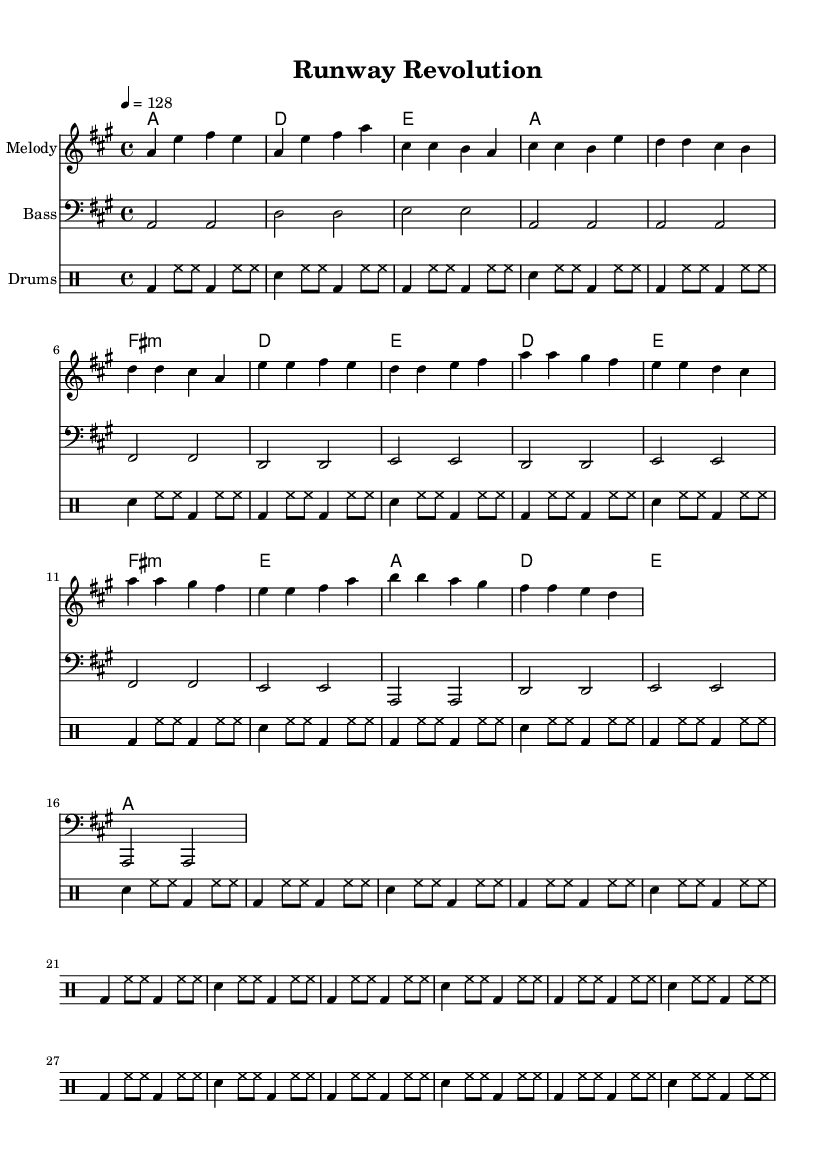What is the key signature of this music? The key signature is A major, which has three sharps: F#, C#, and G#. This is indicated at the beginning of the score.
Answer: A major What is the time signature of this piece? The time signature is 4/4, which means there are four beats in a measure and the quarter note gets one beat. This is shown at the beginning of the score.
Answer: 4/4 What is the tempo marking of the piece? The tempo marking indicates a speed of 128 beats per minute, noted with "4 = 128". This tells the musician how fast to play the piece.
Answer: 128 How many measures are in the Chorus section? The Chorus section consists of four measures, as can be seen clearly in the music notation. Each measure can be counted individually.
Answer: 4 What is the pattern of the bassline in the Intro section? The bassline in the Intro section consists of alternating notes: A and D, and the rhythm follows the same pattern. This is determined by observing the note arrangement in the corresponding measures.
Answer: Alternating notes In which section does the melody go higher than the previous section? The Pre-Chorus section houses higher notes compared to the Verse section. This can be identified by observing the relative pitch of the notes in each section.
Answer: Pre-Chorus What lyrical theme is reflected in this piece? The lyrics reflect a theme of self-expression through clothing and personal style, which corresponds to the energetic and fashionable K-Pop genre. This can be inferred from the overall essence the piece embodies lyrically and musically.
Answer: Self-expression 